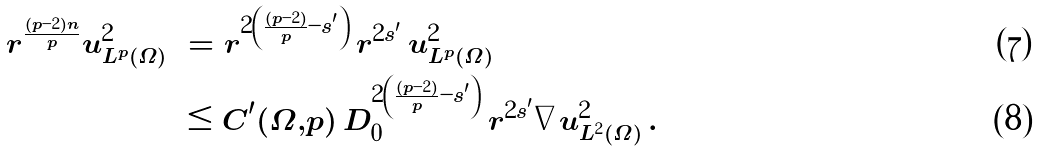Convert formula to latex. <formula><loc_0><loc_0><loc_500><loc_500>r ^ { \frac { ( p - 2 ) n } { p } } \| u \| ^ { 2 } _ { L ^ { p } ( \Omega ) } & = r ^ { 2 \left ( \frac { ( p - 2 ) } { p } - s ^ { \prime } \right ) } \, r ^ { 2 s ^ { \prime } } \, \| u \| ^ { 2 } _ { L ^ { p } ( \Omega ) } \\ & \leq C ^ { \prime } ( \Omega , p ) \, D _ { 0 } ^ { 2 \left ( \frac { ( p - 2 ) } { p } - s ^ { \prime } \right ) } \, r ^ { 2 s ^ { \prime } } \| \nabla u \| _ { L ^ { 2 } ( \Omega ) } ^ { 2 } \, .</formula> 